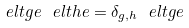<formula> <loc_0><loc_0><loc_500><loc_500>\ e l t { g } { e } \ e l t { h } { e } = \delta _ { g , h } \ e l t { g } { e }</formula> 